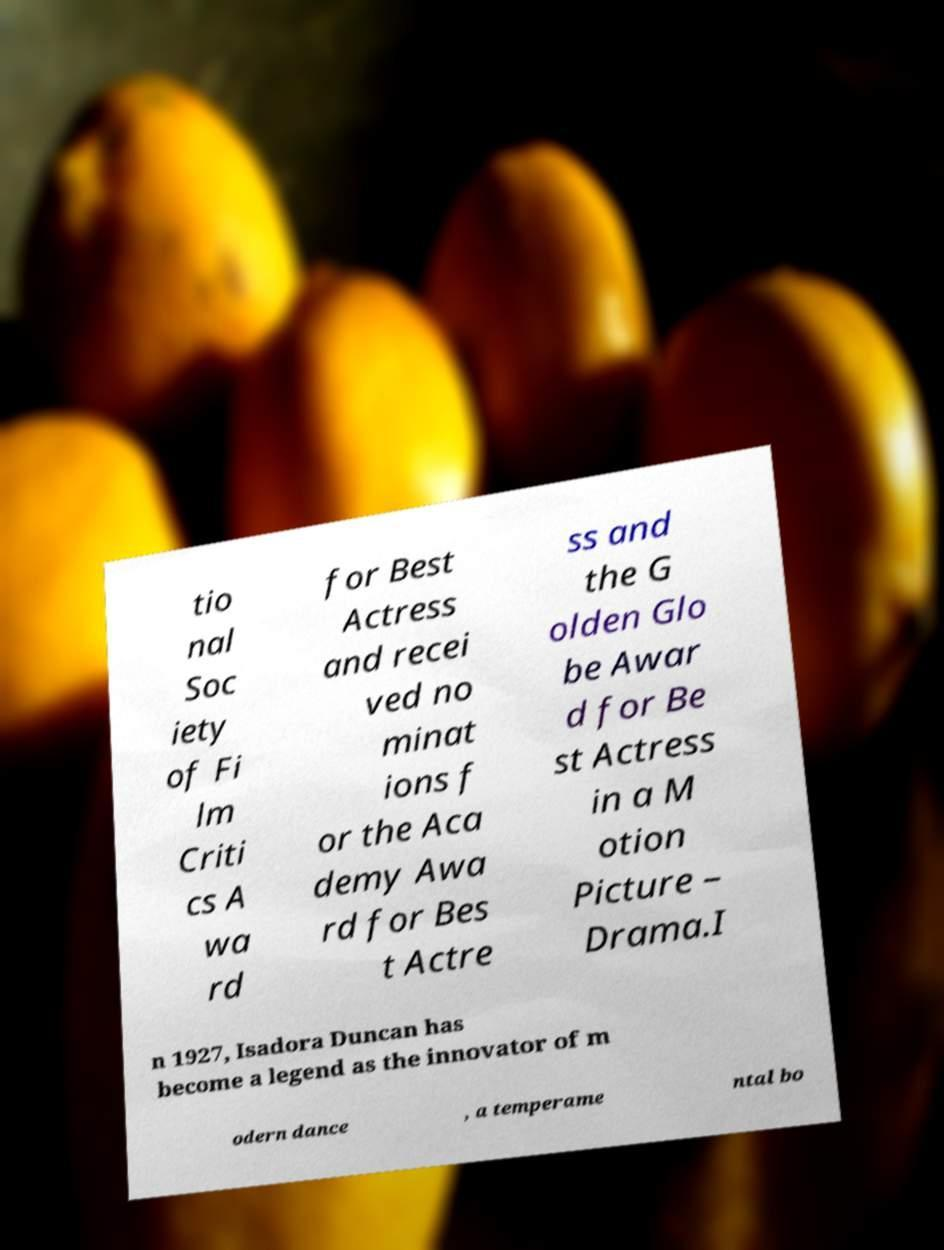Could you extract and type out the text from this image? tio nal Soc iety of Fi lm Criti cs A wa rd for Best Actress and recei ved no minat ions f or the Aca demy Awa rd for Bes t Actre ss and the G olden Glo be Awar d for Be st Actress in a M otion Picture – Drama.I n 1927, Isadora Duncan has become a legend as the innovator of m odern dance , a temperame ntal bo 